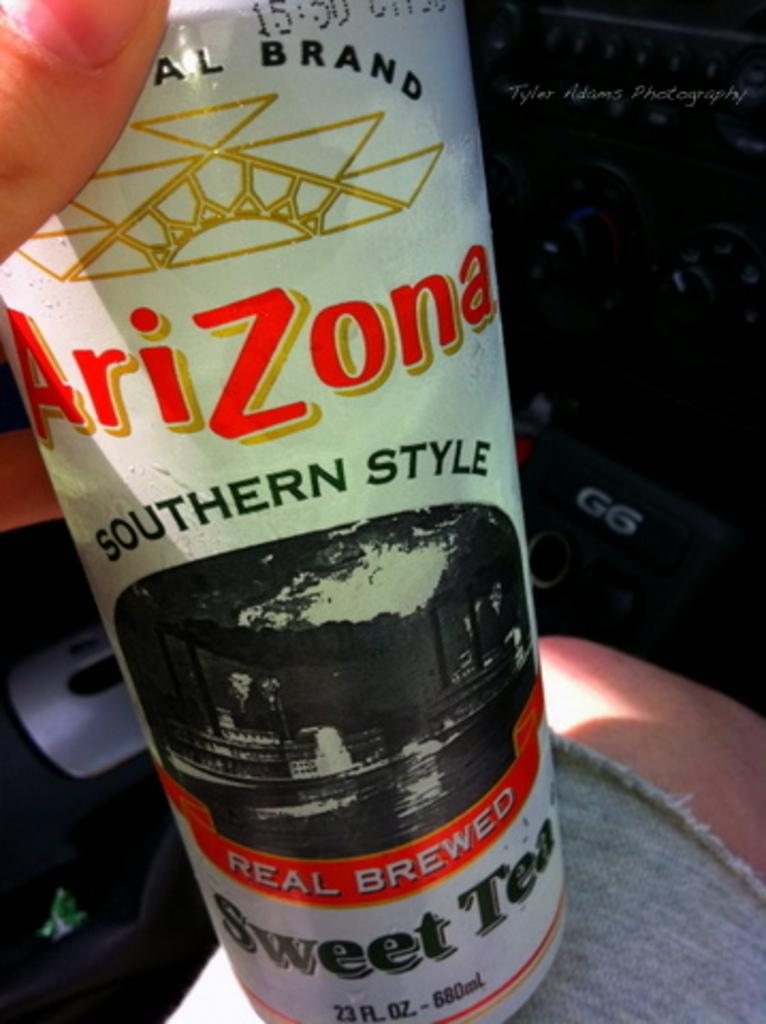Provide a one-sentence caption for the provided image. A person is holding a bottle of Arizona Southern Style Sweet Tea. 